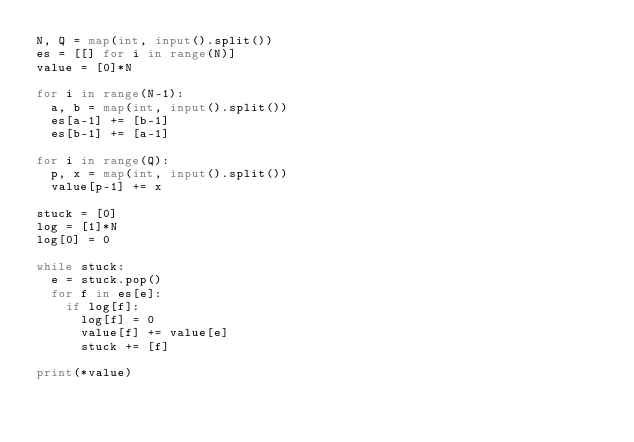Convert code to text. <code><loc_0><loc_0><loc_500><loc_500><_Python_>N, Q = map(int, input().split())
es = [[] for i in range(N)]
value = [0]*N

for i in range(N-1):
  a, b = map(int, input().split())
  es[a-1] += [b-1]
  es[b-1] += [a-1]

for i in range(Q):
  p, x = map(int, input().split())
  value[p-1] += x

stuck = [0]
log = [1]*N
log[0] = 0

while stuck:
  e = stuck.pop()
  for f in es[e]:
    if log[f]:
      log[f] = 0
      value[f] += value[e]
      stuck += [f]

print(*value)
</code> 